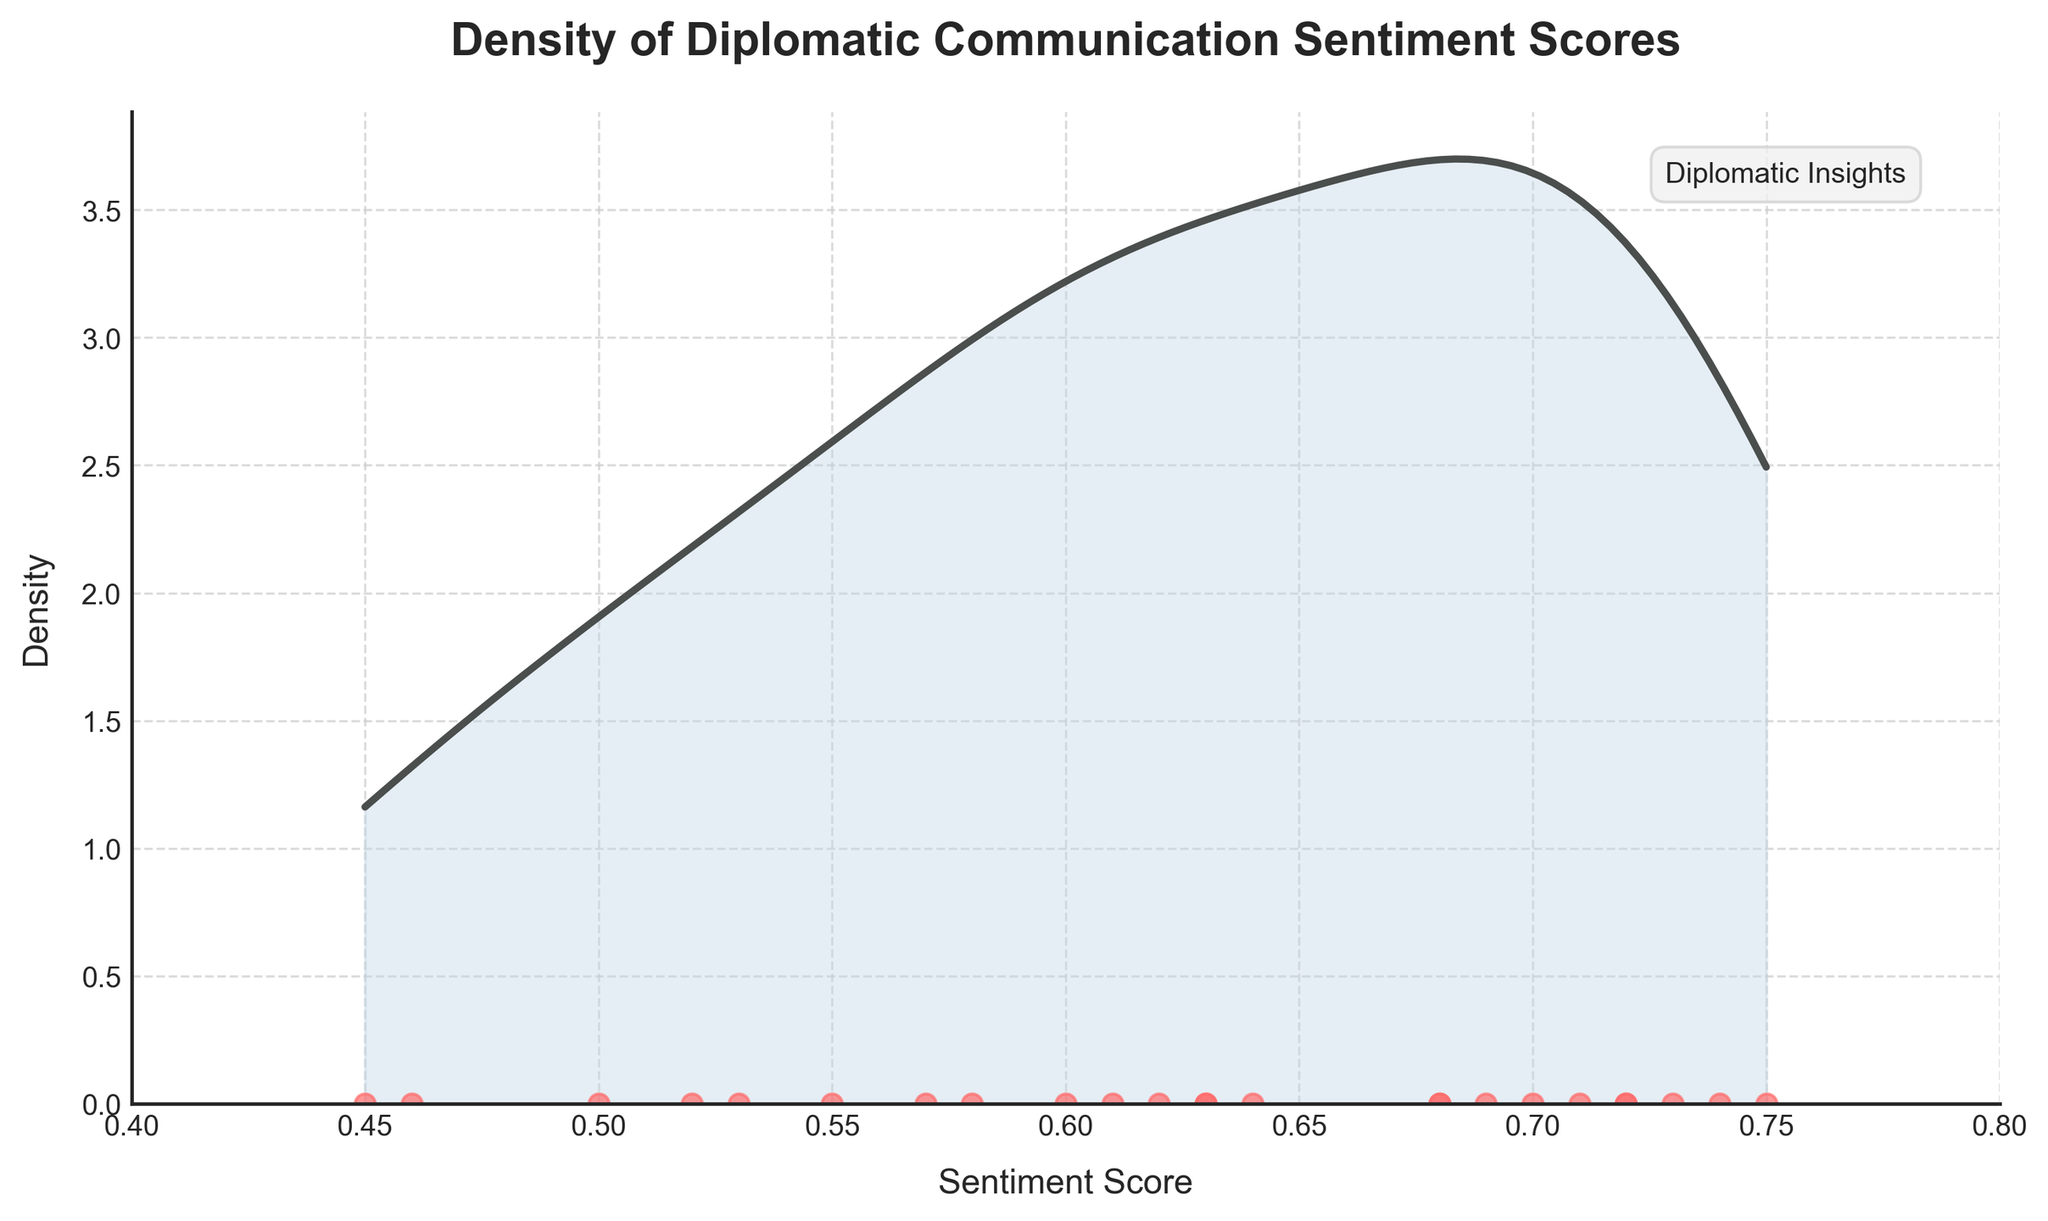What's the title of the plot? The title of the plot is prominently displayed at the top of the figure.
Answer: Density of Diplomatic Communication Sentiment Scores What are the ranges on the x-axis and y-axis? The ranges are indicated by the x and y-axis labels and the extent of the tick marks. The x-axis ranges from 0.4 to 0.8, and the y-axis starts at 0 and goes up to a certain positive value.
Answer: x-axis: 0.4 to 0.8, y-axis: starts at 0 How many data points are plotted in the figure? Each individual data point is represented by a red dot on the x-axis. By counting them, we can determine the total number. There are 24 data points.
Answer: 24 Which country's sentiment score had the highest density? The highest density can be found at the peak of the density curve.
Answer: Canada What can you say about the sentiment score for Russia? Referring to the red dots and their corresponding positions on the x-axis, Russia has relatively low sentiment scores near 0.45.
Answer: Low, around 0.45 What is the overall trend in the density of sentiment scores? The density plot shows how sentiment scores are distributed, with a higher density around mid to higher sentiment scores. The peak suggests most scores are around 0.7.
Answer: Higher density around 0.7 How does the sentiment score for China compare over the periods given? By identifying the red dots corresponding to China (0.55 and 0.53) and comparing their positions, China's sentiment scores are quite similar and close to each other.
Answer: Very similar, around 0.55 and 0.53 Which country shows a noticeable change in sentiment score between the given time periods? Comparing the positions of the red dots for each country between years, the United Kingdom shows a slight drop from 0.63 to 0.61.
Answer: United Kingdom How does the density of diplomatic communications’ sentiment scores over time reflect on diplomatic trends? The overall density and distribution of sentiment scores suggest the diplomatic communication trends are generally positive, with most scores clustering around the higher end.
Answer: Reflects generally positive trends 